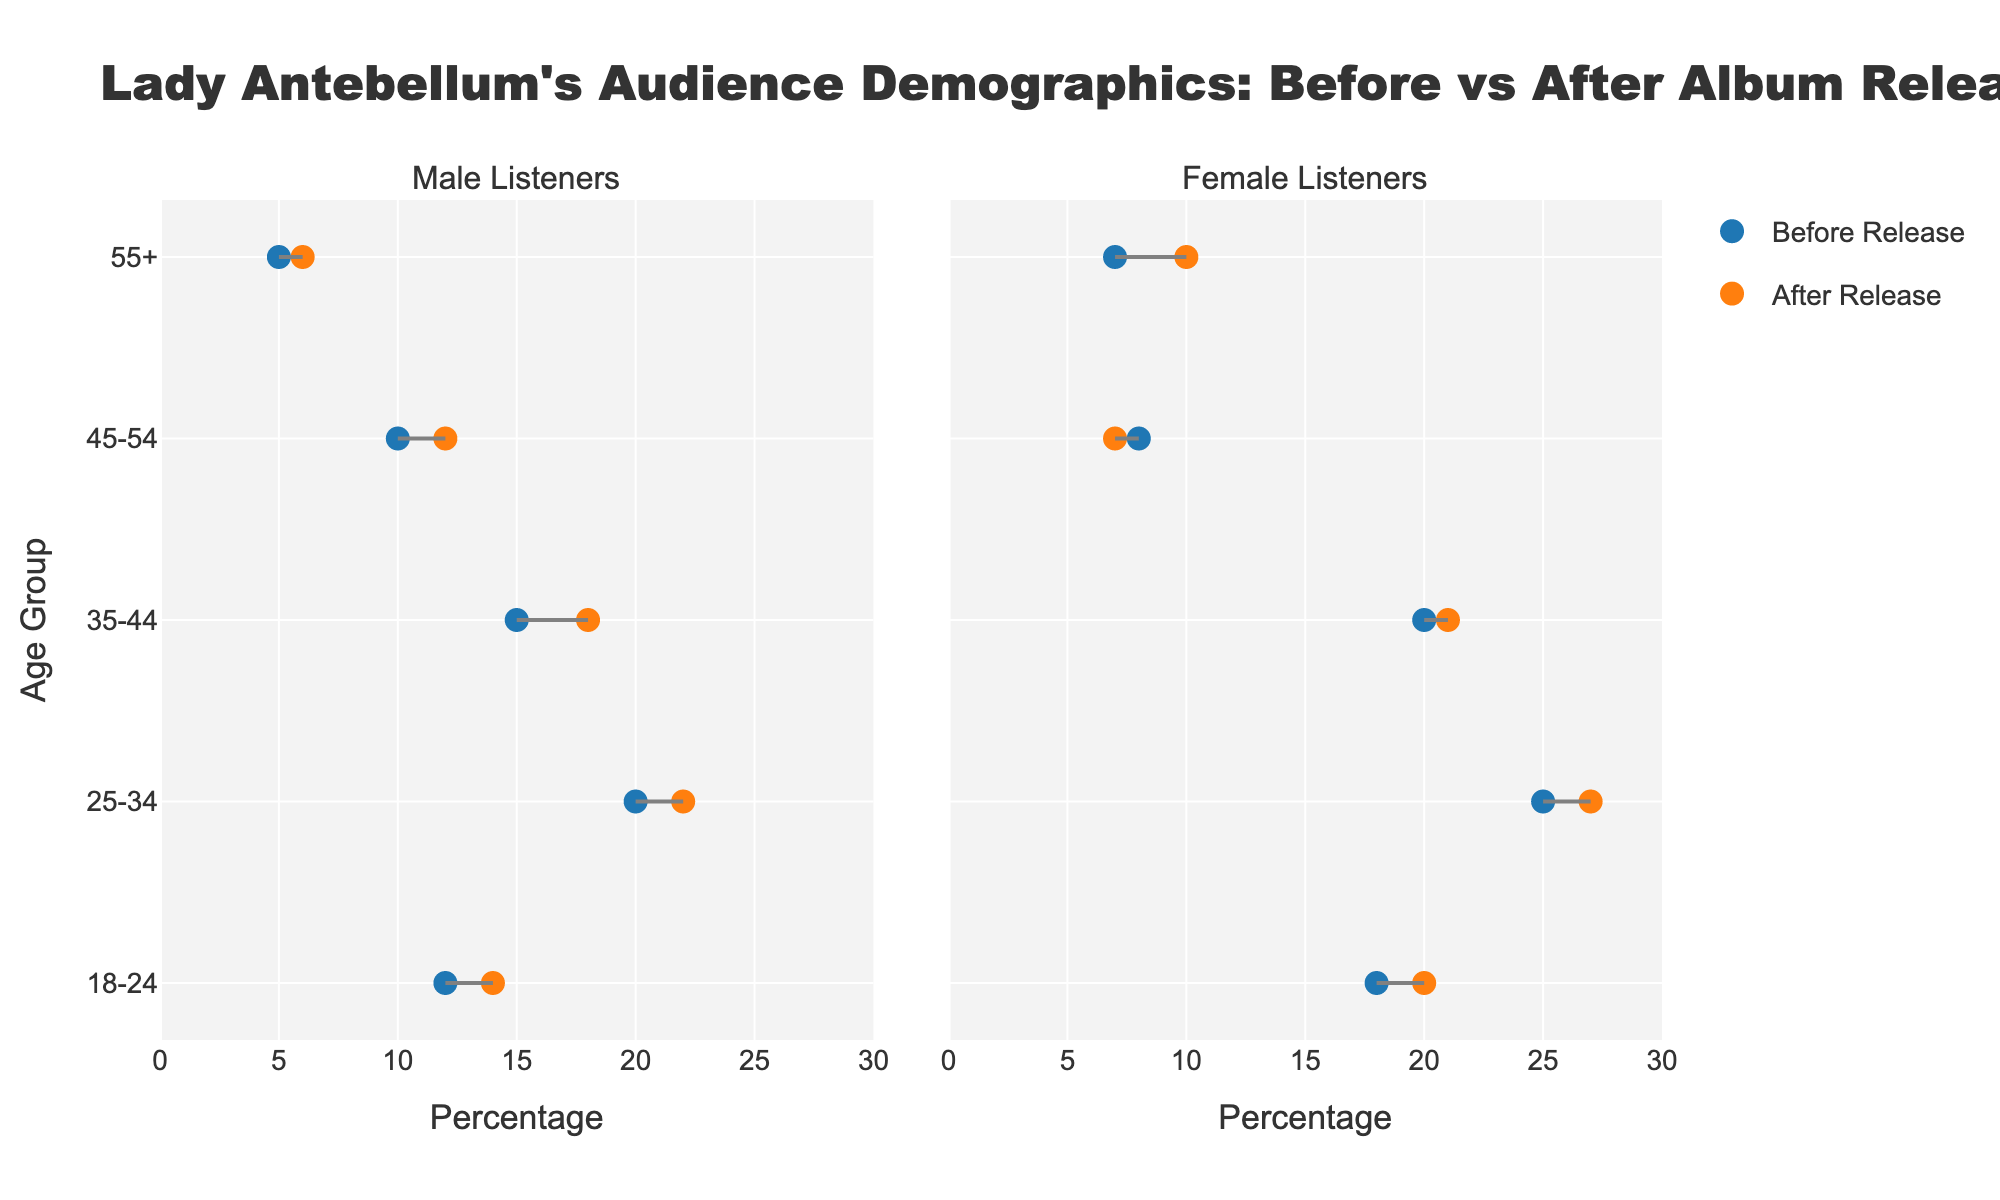What is the title of the figure? The title of the figure is displayed at the top of the plot and provides an overview of the content being presented. It reads "Lady Antebellum's Audience Demographics: Before vs After Album Release".
Answer: Lady Antebellum's Audience Demographics: Before vs After Album Release What percentages of female listeners in the 25-34 age group before and after the release? To find the percentages, look at the markers in the female listeners panel for the 25-34 age group. The before release percentage is 25%, and the after release percentage is 27%.
Answer: 25%, 27% Which gender has an increase in percentage for the 18-24 age group after the album release? Compare the markers connected by the lines for both genders in the 18-24 age group. Both male and female listeners show an increase, but it is clearer if you look at the direction of the lines.
Answer: Both Which age group among female listeners has decreased in percentage after the release? Look at the lines in the female listeners' panel. The 45-54 age group shows a decrease as the line slopes downward from the before to after marker.
Answer: 45-54 How much did the percentage of male listeners aged 35-44 increase after the release? Identify the markers for male listeners aged 35-44. The increase is calculated by subtracting the before percentage (15%) from the after percentage (18%) resulting in an increase of 3 percentage points.
Answer: 3% What is the total increase in percentage of listeners aged 55+ after the release for both genders combined? Calculate the increase for each gender separately and then sum them. For males, the increase is from 5% to 6% resulting in 1%. For females, the increase is from 7% to 10% resulting in 3%. Adding these together gives a total increase of 4 percentage points.
Answer: 4% Compare the changes in audience demographics for the 25-34 age group between males and females. Both genders show an increase in percentages. For males, the increase is from 20% to 22%, a 2% increase. For females, the increase is from 25% to 27%, also a 2% increase.
Answer: Same increase What percentage point changes are observed for female listeners aged 55+ after the release? For female listeners aged 55+, the before release percentage is 7%, and the after release percentage is 10%. The percentage point change is calculated as 10% - 7%, resulting in a 3% increase.
Answer: 3% Identify the age group and gender with the highest percentage before the release. Check the maximum data point in both panels before the release. The 25-34 age group for female listeners has the highest percentage at 25%.
Answer: Female, 25-34 